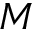Convert formula to latex. <formula><loc_0><loc_0><loc_500><loc_500>M</formula> 